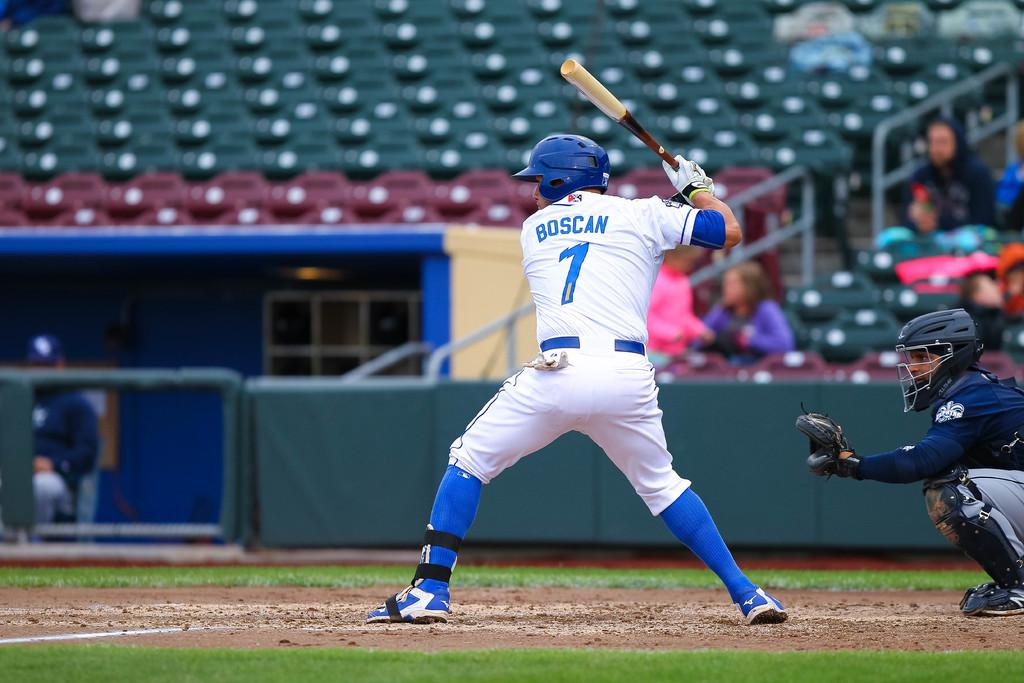Provide a one-sentence caption for the provided image. A baseball player called Boscan with a number 7 on hi shsirt readies to hit the ball with the catcher sat just behind him. 